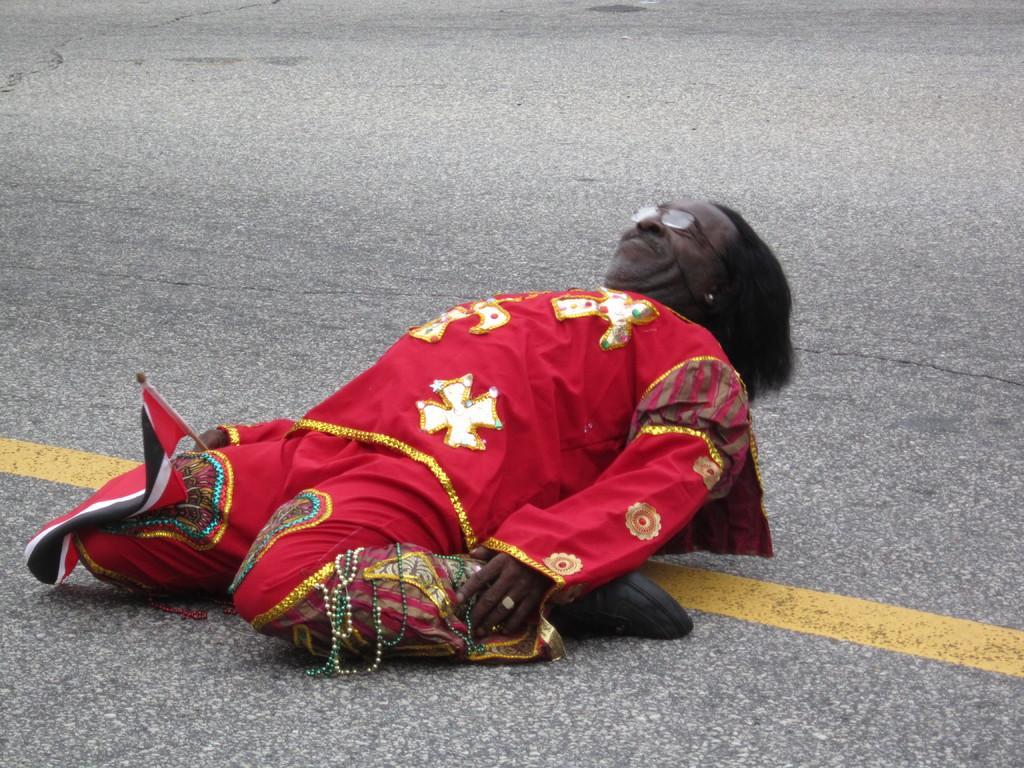Please provide a concise description of this image. The person wearing red dress is sitting on his legs on the road and lying down. 